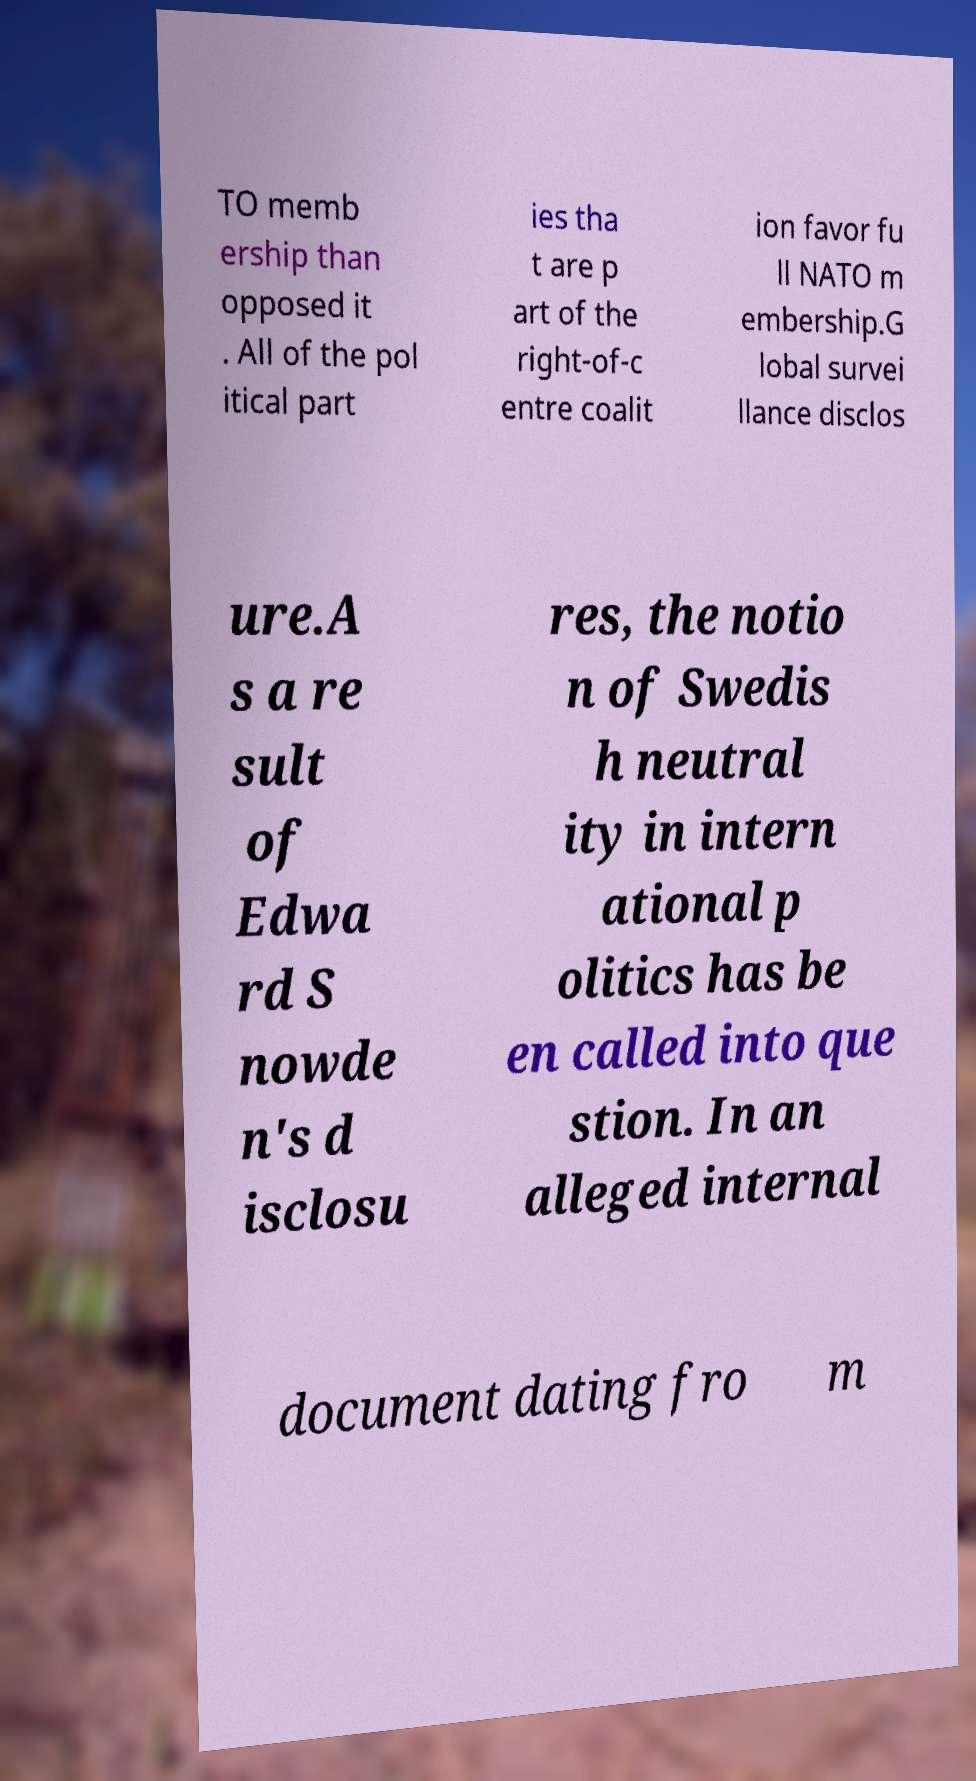Could you extract and type out the text from this image? TO memb ership than opposed it . All of the pol itical part ies tha t are p art of the right-of-c entre coalit ion favor fu ll NATO m embership.G lobal survei llance disclos ure.A s a re sult of Edwa rd S nowde n's d isclosu res, the notio n of Swedis h neutral ity in intern ational p olitics has be en called into que stion. In an alleged internal document dating fro m 